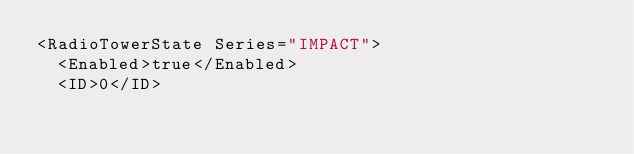<code> <loc_0><loc_0><loc_500><loc_500><_XML_><RadioTowerState Series="IMPACT">
  <Enabled>true</Enabled>
  <ID>0</ID></code> 